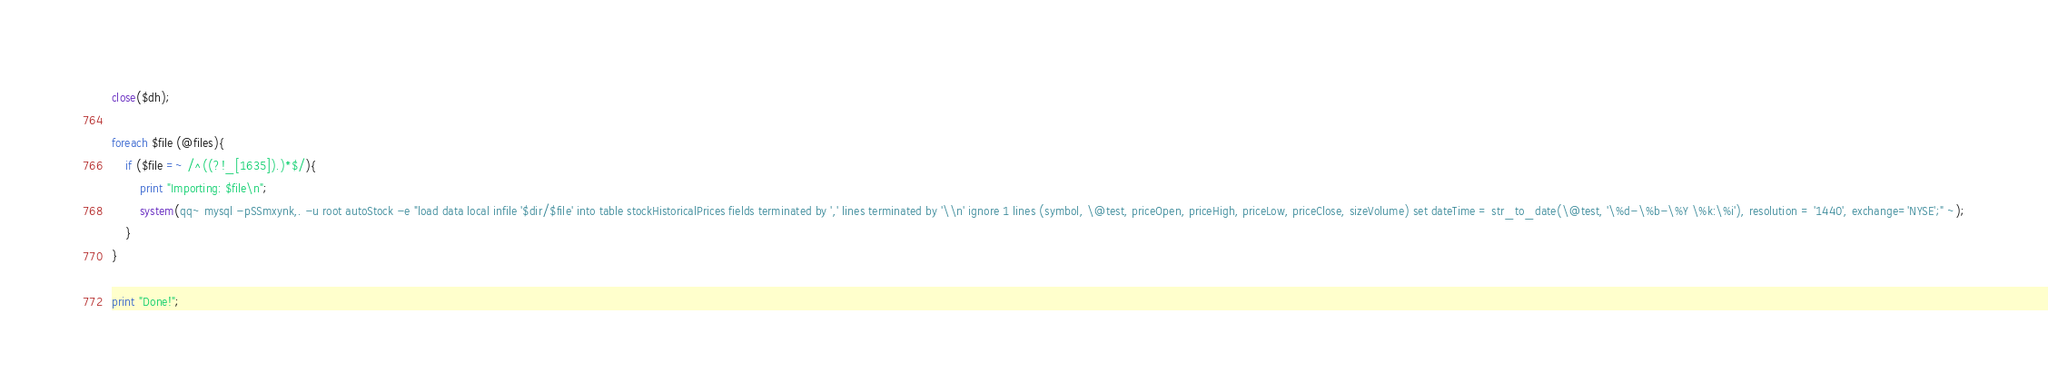<code> <loc_0><loc_0><loc_500><loc_500><_Perl_>close($dh);

foreach $file (@files){
	if ($file =~ /^((?!_[1635]).)*$/){
		print "Importing: $file\n";		
		system(qq~ mysql -pSSmxynk,. -u root autoStock -e "load data local infile '$dir/$file' into table stockHistoricalPrices fields terminated by ',' lines terminated by '\\n' ignore 1 lines (symbol, \@test, priceOpen, priceHigh, priceLow, priceClose, sizeVolume) set dateTime = str_to_date(\@test, '\%d-\%b-\%Y \%k:\%i'), resolution = '1440', exchange='NYSE';" ~);
	}    
}

print "Done!";</code> 